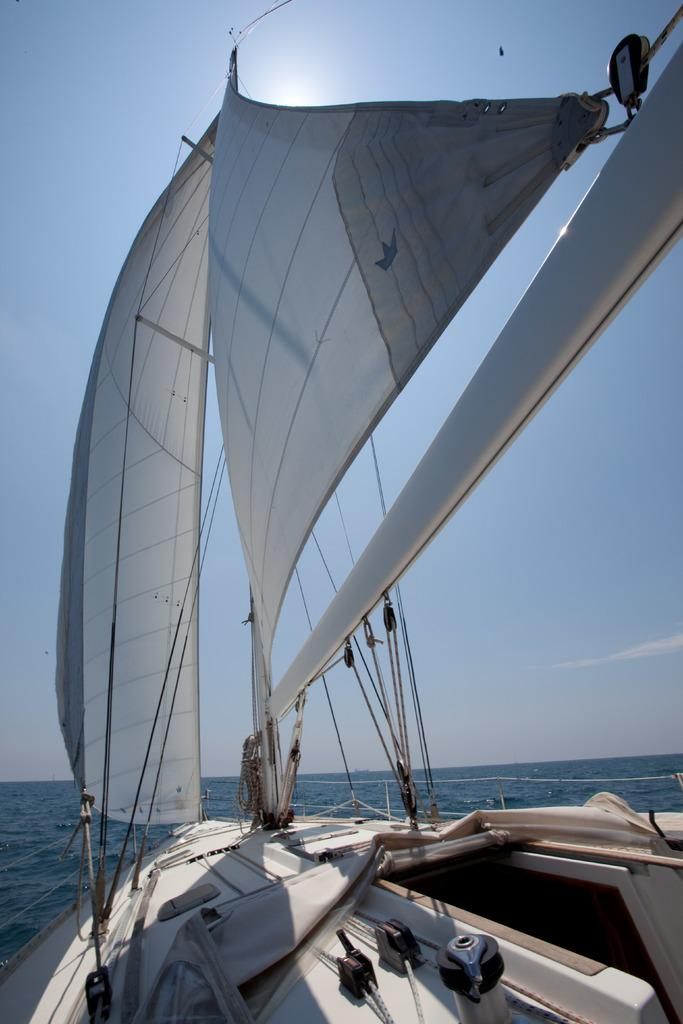What is the main subject of the image? The main subject of the image is a ship. Where is the ship located in the image? The ship is on the water in the image. What else can be seen in the image besides the ship? The sky is visible at the top of the image. What type of appliance is being used by the boy in the image? There is no boy or appliance present in the image; it features a ship on the water with the sky visible at the top. 